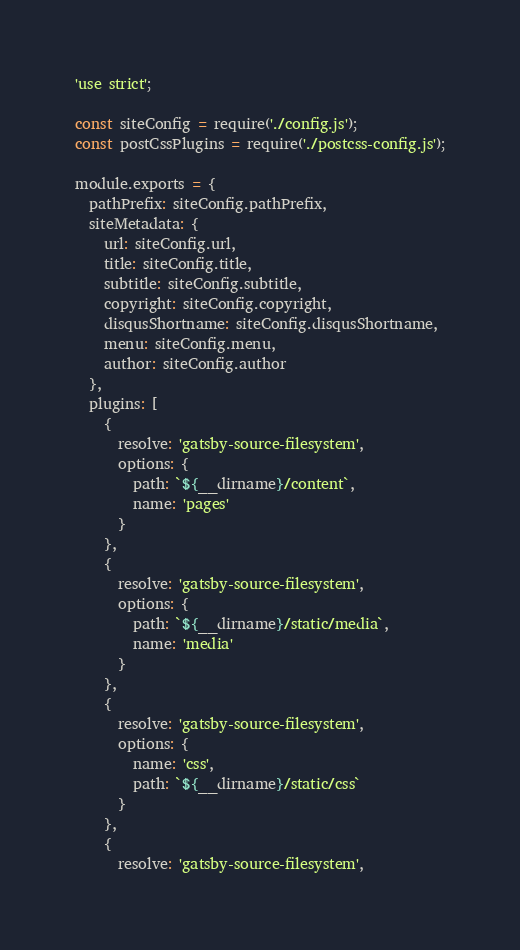<code> <loc_0><loc_0><loc_500><loc_500><_JavaScript_>'use strict';

const siteConfig = require('./config.js');
const postCssPlugins = require('./postcss-config.js');

module.exports = {
  pathPrefix: siteConfig.pathPrefix,
  siteMetadata: {
    url: siteConfig.url,
    title: siteConfig.title,
    subtitle: siteConfig.subtitle,
    copyright: siteConfig.copyright,
    disqusShortname: siteConfig.disqusShortname,
    menu: siteConfig.menu,
    author: siteConfig.author
  },
  plugins: [
    {
      resolve: 'gatsby-source-filesystem',
      options: {
        path: `${__dirname}/content`,
        name: 'pages'
      }
    },
    {
      resolve: 'gatsby-source-filesystem',
      options: {
        path: `${__dirname}/static/media`,
        name: 'media'
      }
    },
    {
      resolve: 'gatsby-source-filesystem',
      options: {
        name: 'css',
        path: `${__dirname}/static/css`
      }
    },
    {
      resolve: 'gatsby-source-filesystem',</code> 